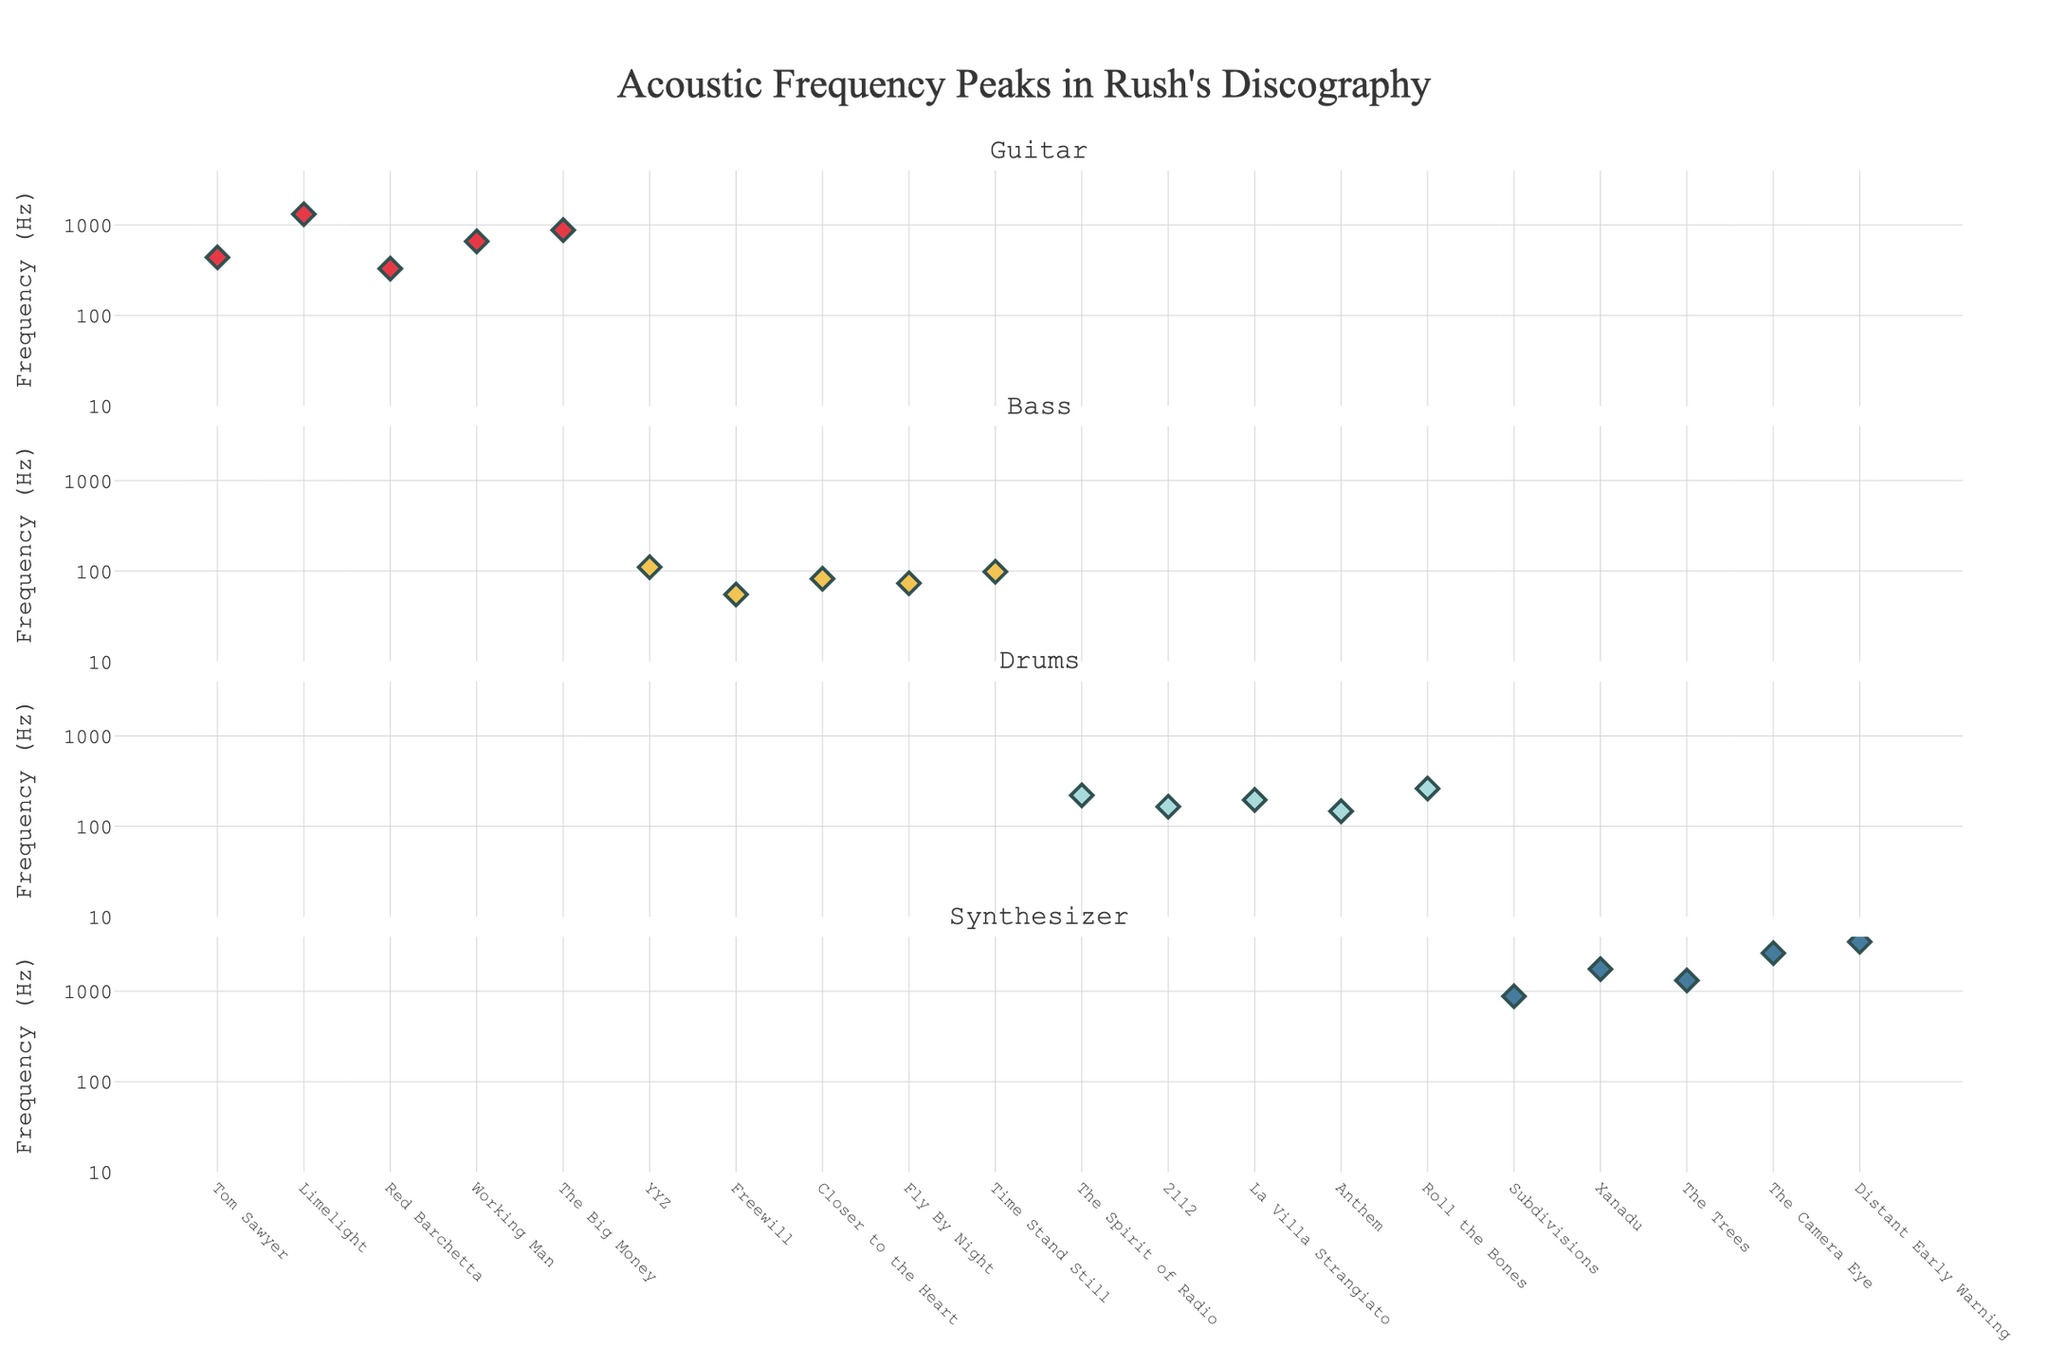What is the title of the plot? The title of the plot is displayed at the top center of the figure. It reads "Acoustic Frequency Peaks in Rush's Discography."
Answer: Acoustic Frequency Peaks in Rush's Discography How many instruments are represented in the plot? Each subplot is dedicated to one instrument, and there are four subplots vertically aligned.
Answer: 4 What is the frequency peak of 'YYZ' for the Bass? Locate the 'Bass' subplot and find the marker labeled 'YYZ.' The y-axis value shows the frequency.
Answer: 110 Hz Which song has the highest frequency peak for the Synthesizer? Find the peaks for the Synthesizer in its subplot and identify the highest point. The corresponding song next to it is 'Distant Early Warning.'
Answer: Distant Early Warning How many songs have a frequency peak above 1000 Hz, and which instruments do they belong to? Look for markers above the 1000 Hz mark across all subplots and count them. There are 4 markers: 1320 Hz (Guitar, Limelight), 1320 Hz (Synthesizer, The Trees), 3520 Hz (Synthesizer, Distant Early Warning), and 2640 Hz (Synthesizer, The Camera Eye).
Answer: 4, Guitar (1), Synthesizer (3) Which instrument has the lowest average frequency peak, and what is the value? Calculate the average frequency for each instrument: sum the frequencies and divide by the number of songs for each instrument. 
   - Guitar: (440 + 1320 + 330 + 660 + 880)/5 = 726 Hz
   - Bass: (110 + 55 + 82 + 73 + 98)/5 = 83.6 Hz
   - Drums: (220 + 165 + 196 + 147 + 262)/5 = 198 Hz
   - Synthesizer: (880 + 1760 + 1320 + 3520 + 2640)/5 = 1844 Hz
The Bass has the lowest average frequency peak.
Answer: Bass, 83.6 Hz Compare the frequency peaks of the song 'Intro' for all instruments. Which instrument has the highest peak and what is the value? Check the frequency peaks for the 'Intro' position across each subplot: Guitar (440 Hz), Synthesizer (1760 Hz), Drums (262 Hz), and Bass (73 Hz). The Synthesizer has the highest peak.
Answer: Synthesizer, 1760 Hz What is the median frequency peak for the Drums? List all frequency peaks for the Drums: 220, 165, 196, 147, 262. Sort them: 147, 165, 196, 220, 262. The median is the middle value, which is 196 Hz.
Answer: 196 Hz Which song has the lowest frequency peak for Bass, and what is the peak? Locate the Bass subplot and identify the smallest y-axis value. The corresponding song is 'Freewill,' with a frequency peak of 55 Hz.
Answer: Freewill, 55 Hz 